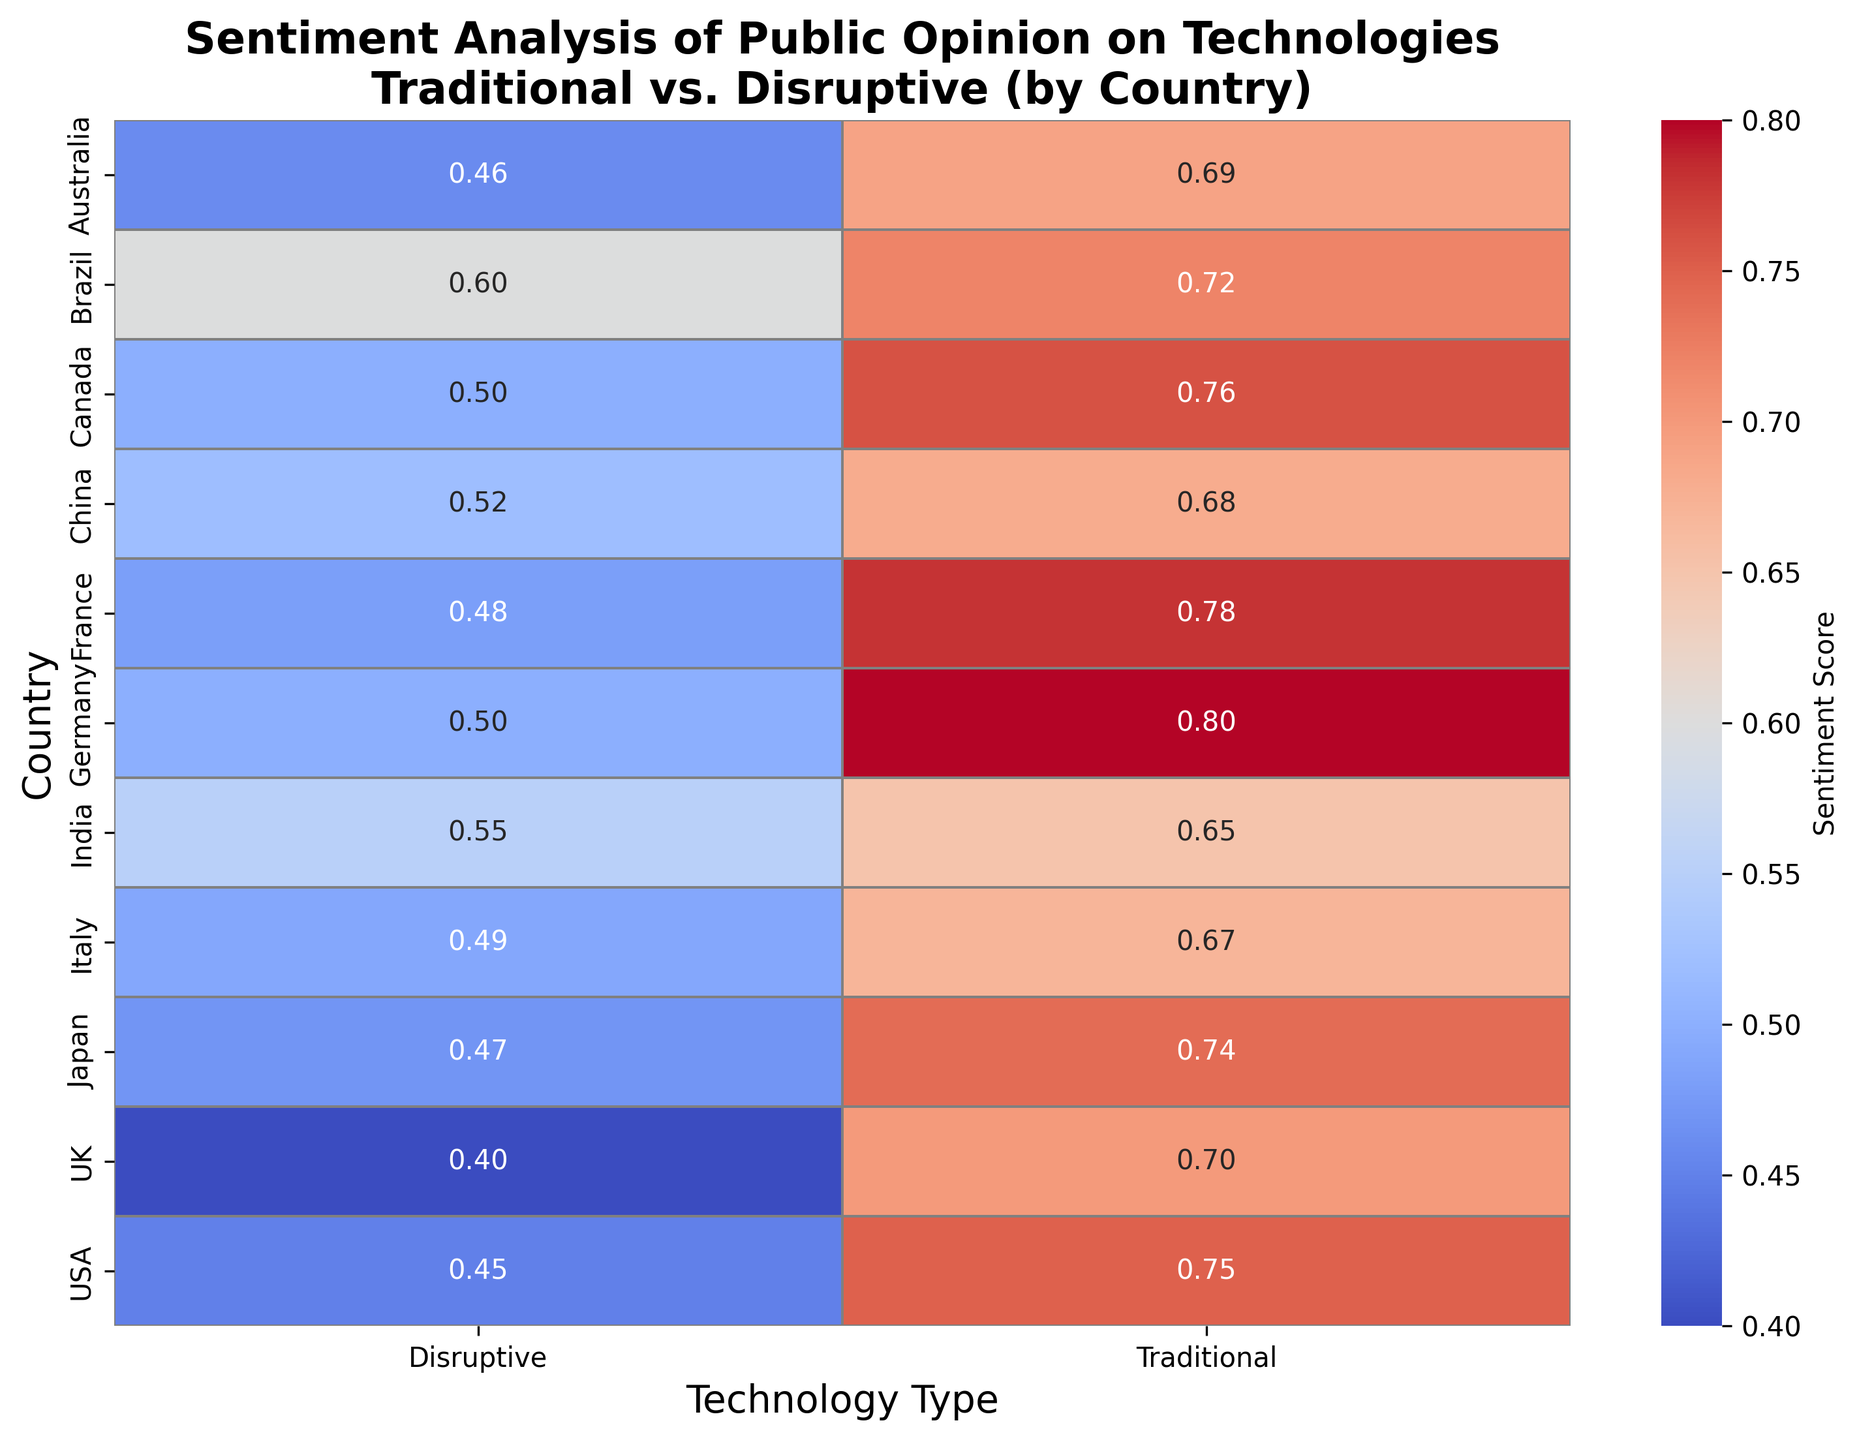Which country has the highest sentiment score for traditional technology? Examine the "Traditional" column and find the highest value. Germany has the highest sentiment score of 0.80 for traditional technology.
Answer: Germany Which country is more positive towards disruptive technology, India or China? Look at the "Disruptive" column for India and China. India has a score of 0.55 and China has a score of 0.52. Therefore, India is more positive towards disruptive technology.
Answer: India By how much does the USA's sentiment score for traditional technology exceed that for disruptive technology? First, find the sentiment scores for the USA: Traditional is 0.75, Disruptive is 0.45. Subtract 0.45 from 0.75 to get the difference.
Answer: 0.30 Is there any country where the sentiment score for disruptive technology equals its sentiment score for traditional technology? Scan both columns for any country that has the same value in both. No country has equal scores for both types of technology.
Answer: No Which country has the smallest difference in sentiment scores between traditional and disruptive technologies? Calculate the difference between Traditional and Disruptive scores for each country. France and Italy both have differences of 0.29 (0.78 - 0.48 for France, 0.67 - 0.49 for Italy).
Answer: France, Italy Which country appears to be most skeptical of disruptive technology based on sentiment scores? Look at the "Disruptive" column and find the lowest value. The UK has the lowest sentiment score of 0.40 for disruptive technology, indicating the greatest skepticism.
Answer: UK Compare public opinion in Brazil: Is it more favorable towards traditional or disruptive technology? Look at Brazil's sentiment scores: Traditional is 0.72, Disruptive is 0.60. Brazil has a higher score for traditional technology.
Answer: Traditional Calculate the average sentiment score for traditional technology across all countries. Sum all values in the "Traditional" column and divide by the number of countries (10). The sum is 7.24, so the average is 7.24 / 10 = 0.724.
Answer: 0.724 Which country shows the most balanced (closely matching) sentiment towards both technologies? Calculate the absolute difference between Traditional and Disruptive scores for each country. Brazil has the smallest difference of 0.12 (0.72 - 0.60).
Answer: Brazil In terms of color intensity, which country's sentiment score for traditional technology contrasts most strongly with its score for disruptive technology? Observe the heatmap colors for each country and compare the contrast between Traditional and Disruptive technology. The USA has a strong contrast, with bright red (0.75) for Traditional and a much cooler color (0.45) for Disruptive.
Answer: USA 